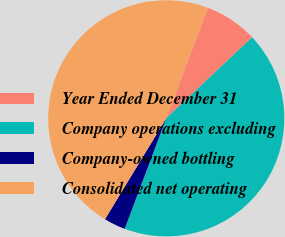Convert chart. <chart><loc_0><loc_0><loc_500><loc_500><pie_chart><fcel>Year Ended December 31<fcel>Company operations excluding<fcel>Company-owned bottling<fcel>Consolidated net operating<nl><fcel>7.24%<fcel>42.76%<fcel>2.96%<fcel>47.04%<nl></chart> 